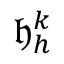Convert formula to latex. <formula><loc_0><loc_0><loc_500><loc_500>\mathfrak { h } _ { h } ^ { k }</formula> 